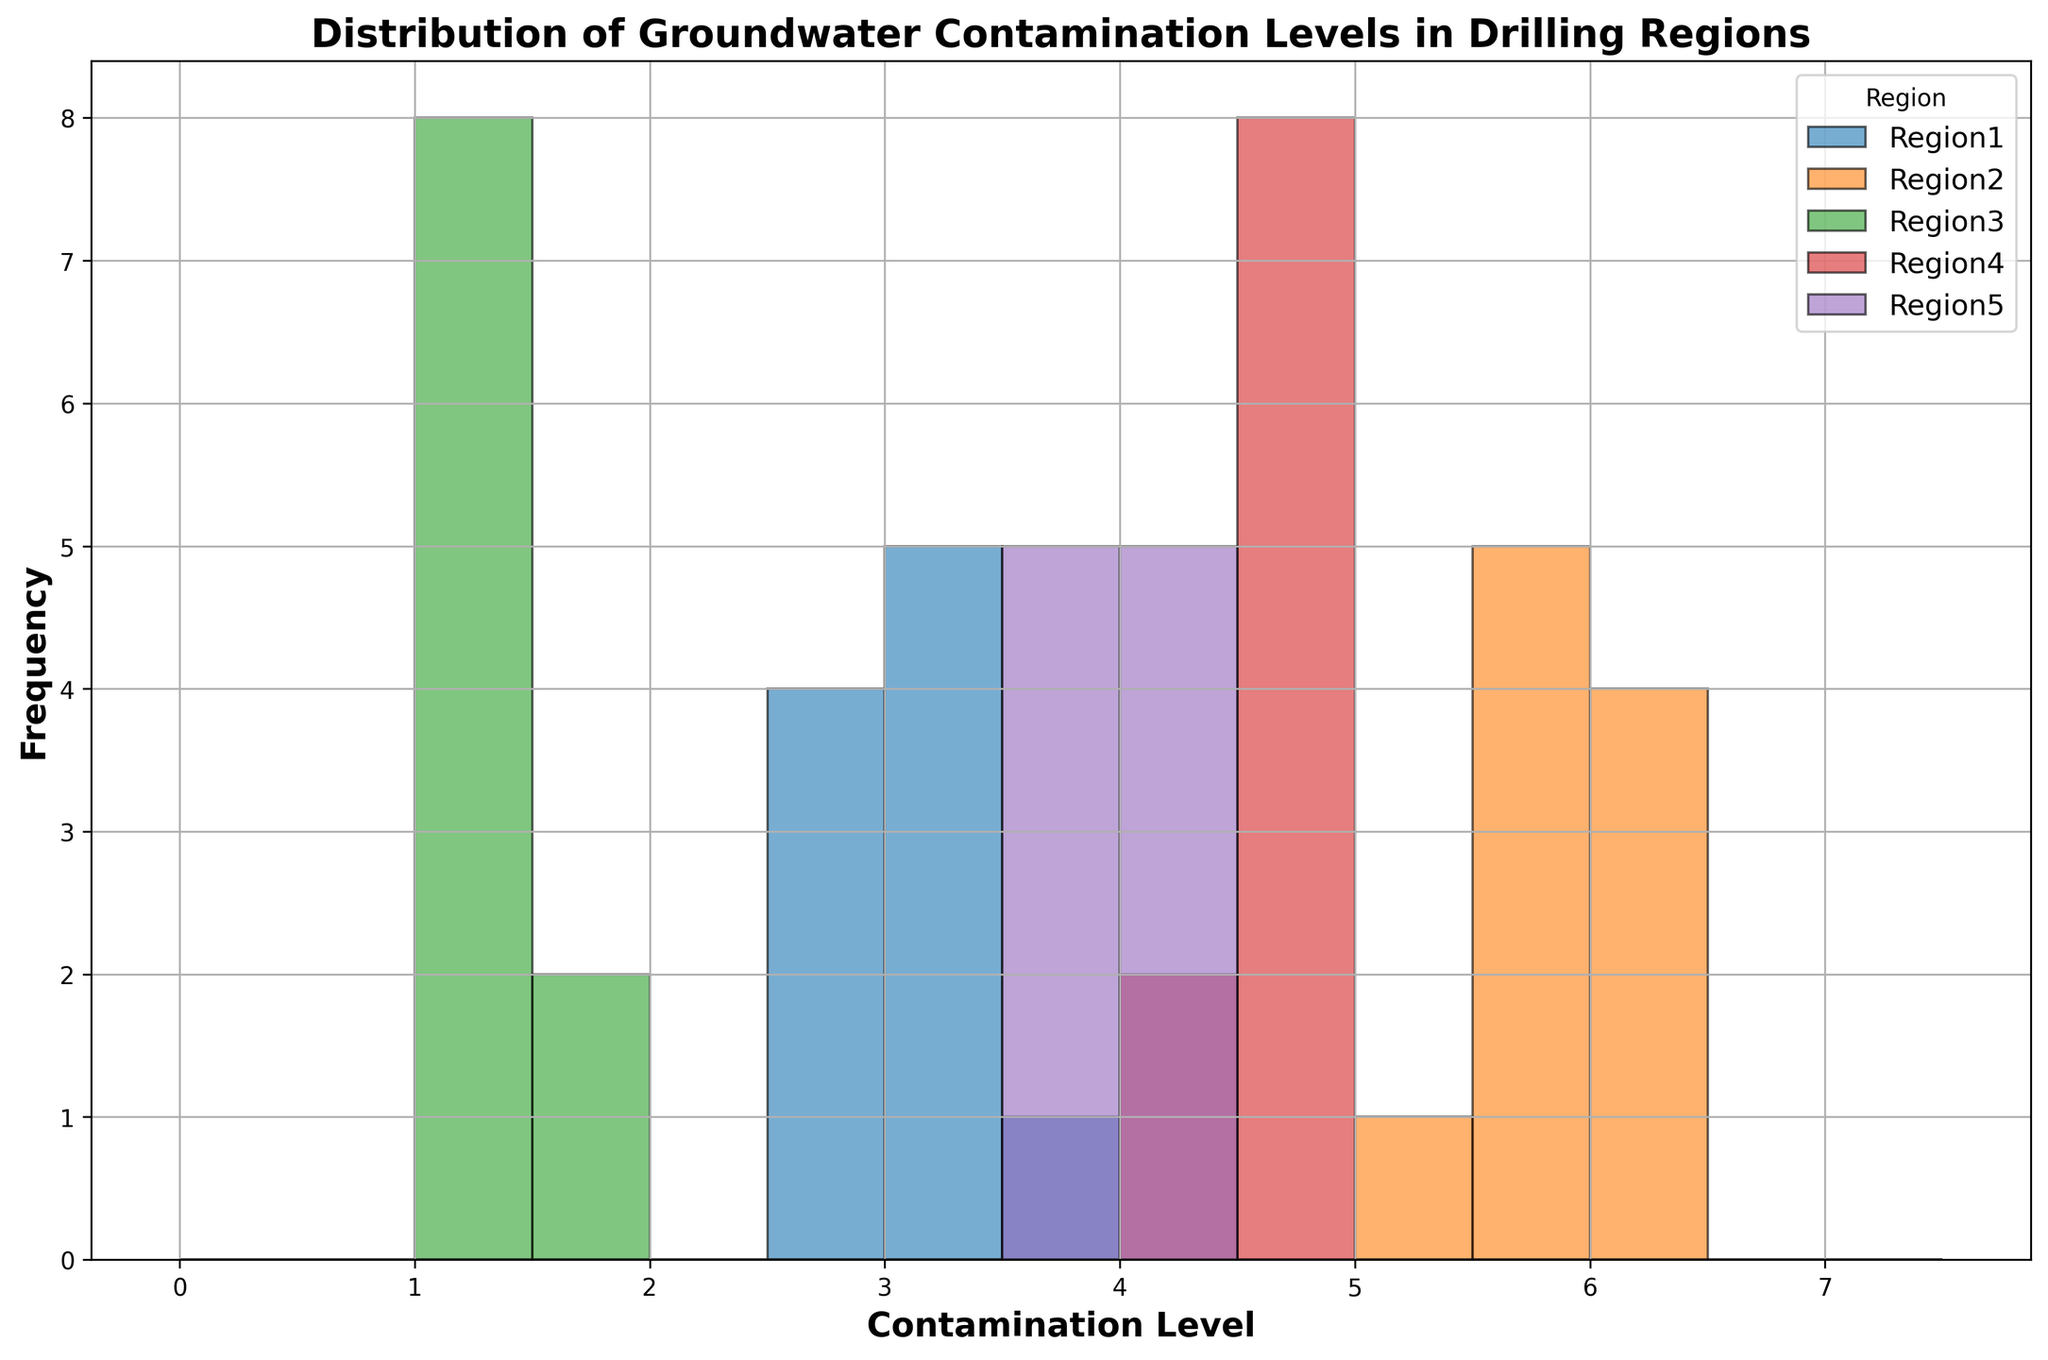Which region has the highest peak in contamination levels based on the histogram? Looking at the histogram, the region with the highest peak will have the tallest bar. The peak frequency is observed where the frequency bar is highest.
Answer: Region2 Which region shows the lowest contamination levels on the histogram? By observing the position of the bar towards the lowest contamination levels, the region with the contamination levels starting from the smallest value will be identified.
Answer: Region3 What is the range of contamination levels observed in Region5? Examine the width of bars associated with Region5. The lowest and highest marked bins give the range.
Answer: 3.7 to 4.3 Which region has the most uniform distribution of contamination levels? Look for the region where the bars have a relatively uniform height, indicating a more even distribution.
Answer: Region3 Compare the average contamination levels between Region1 and Region4. Which region has a higher average? Calculate the midpoints of each bin for both regions and consider the heights of the bars to get an estimate of the total contamination. Region4 generally has higher contamination levels compared to Region1’s distribution.
Answer: Region4 In which region do we observe the widest range of contamination levels? Determine which region’s bins span the widest range from the lowest to the highest contamination levels.
Answer: Region2 Which regions show a bimodal distribution in their contamination levels? Identify regions by the histogram bars showing two distinct peaks or modes. Regions exhibiting two peaks distinguish bimodal distributions.
Answer: None How does the frequency of contamination levels in Region4 compare to Region5? Compare the heights of the bars for Region4 and Region5, seeing which one is generally taller. This shows which region has more frequent contamination levels.
Answer: Region4 has higher frequencies than Region5 Calculate the approximate median contamination level for Region1. The median corresponds to the middle value in a sorted list of contamination levels. Considering the histogram, it will be around the middle of the range where frequencies drop halfway.
Answer: ~3.1 Do all regions have contamination levels greater than 2.0? Examine each region’s leftmost bar in the histogram to see if any contamination levels fall below 2.0.
Answer: No, Region3 has contamination levels below 2.0 